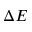Convert formula to latex. <formula><loc_0><loc_0><loc_500><loc_500>\Delta E</formula> 